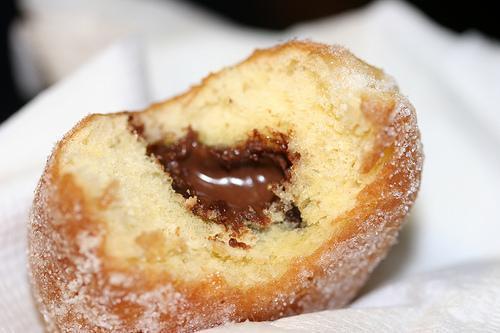How many donuts are there?
Give a very brief answer. 1. 